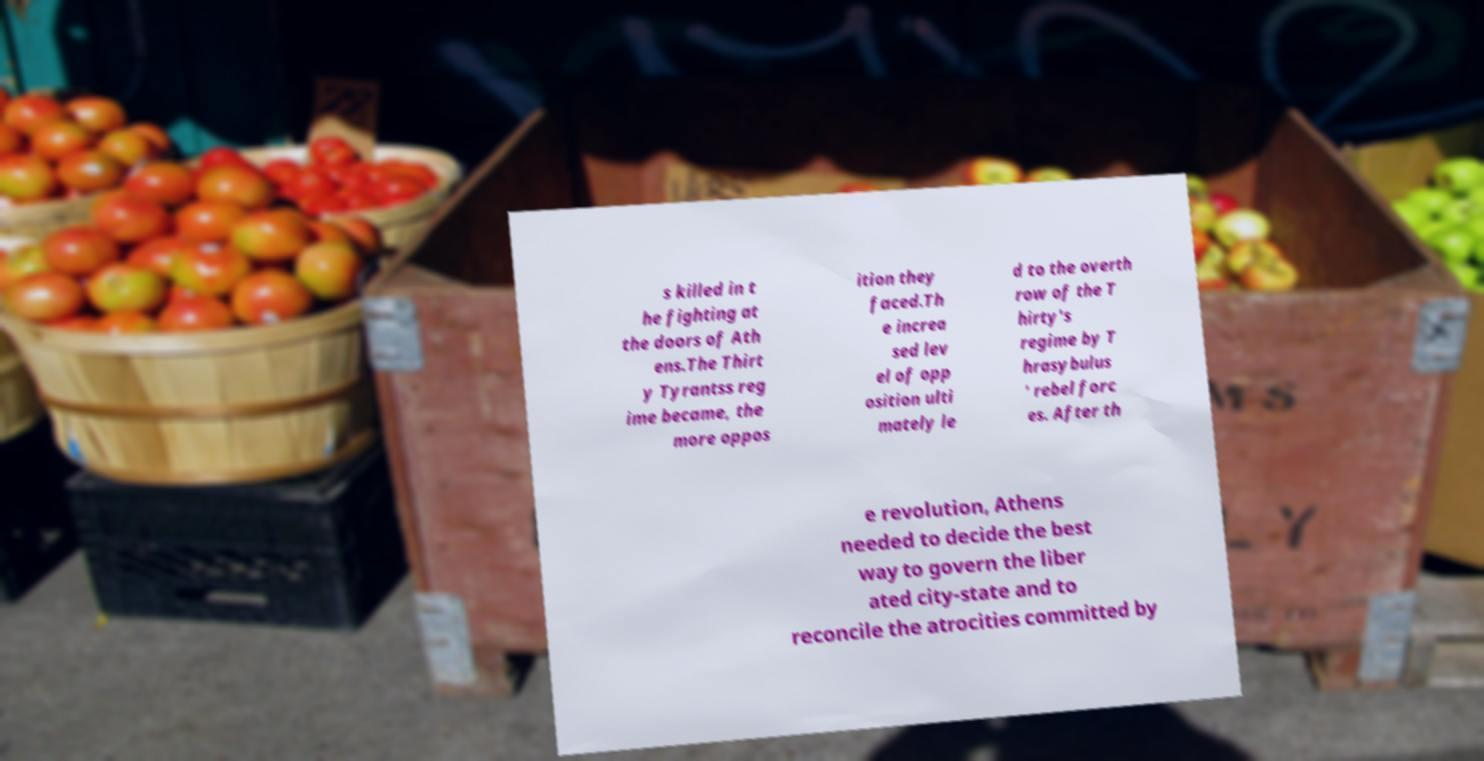Could you assist in decoding the text presented in this image and type it out clearly? s killed in t he fighting at the doors of Ath ens.The Thirt y Tyrantss reg ime became, the more oppos ition they faced.Th e increa sed lev el of opp osition ulti mately le d to the overth row of the T hirty's regime by T hrasybulus ' rebel forc es. After th e revolution, Athens needed to decide the best way to govern the liber ated city-state and to reconcile the atrocities committed by 